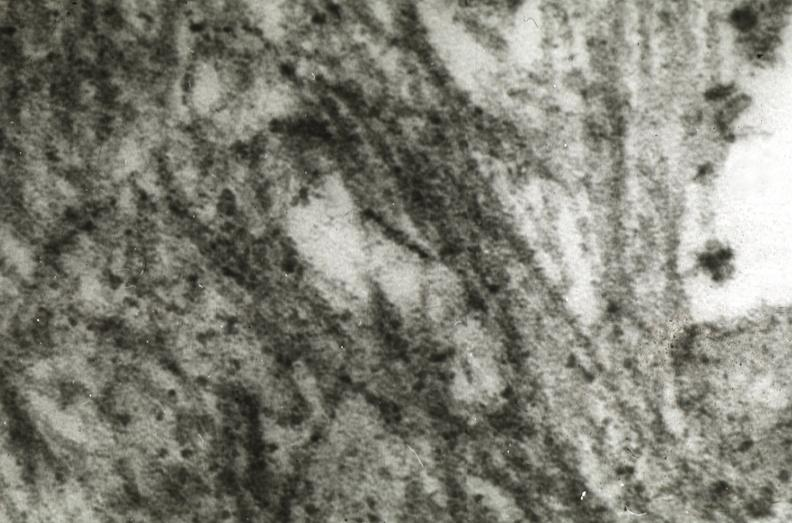what is present?
Answer the question using a single word or phrase. Cardiovascular 